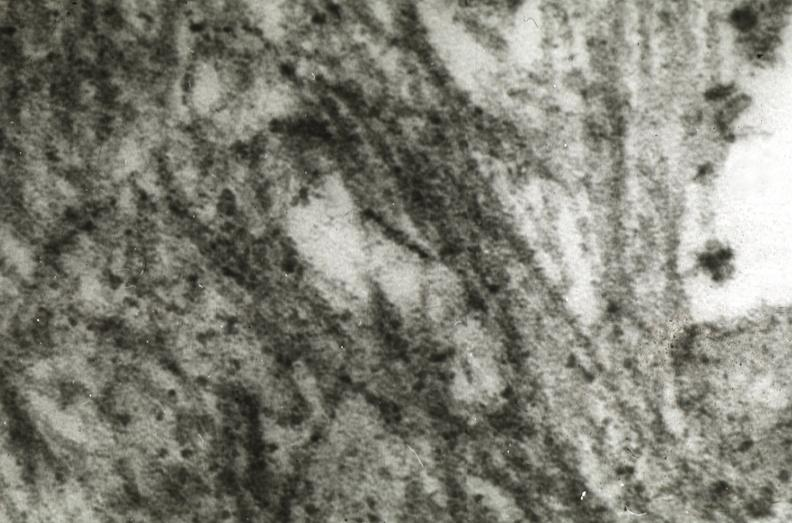what is present?
Answer the question using a single word or phrase. Cardiovascular 